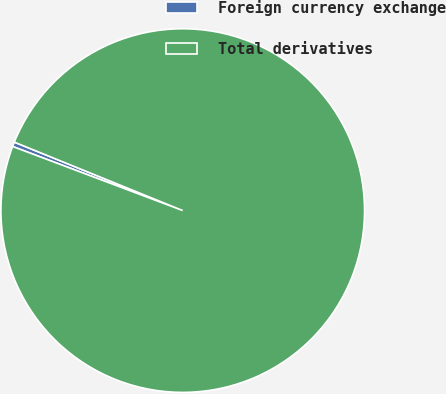Convert chart to OTSL. <chart><loc_0><loc_0><loc_500><loc_500><pie_chart><fcel>Foreign currency exchange<fcel>Total derivatives<nl><fcel>0.41%<fcel>99.59%<nl></chart> 